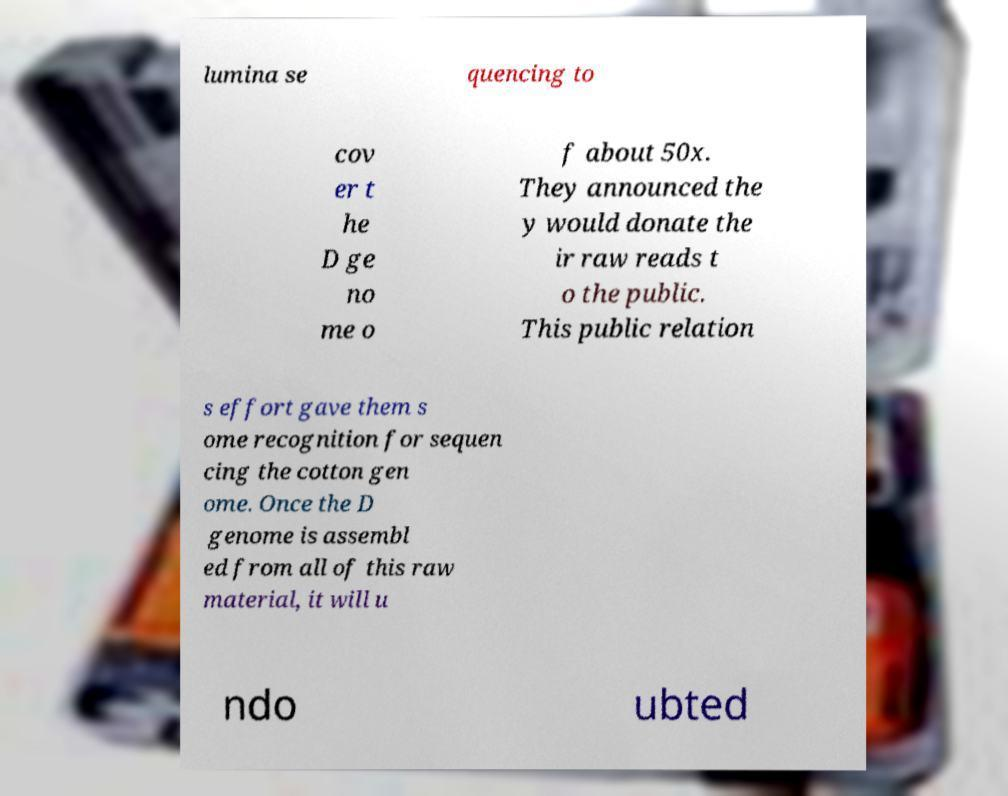Please read and relay the text visible in this image. What does it say? lumina se quencing to cov er t he D ge no me o f about 50x. They announced the y would donate the ir raw reads t o the public. This public relation s effort gave them s ome recognition for sequen cing the cotton gen ome. Once the D genome is assembl ed from all of this raw material, it will u ndo ubted 